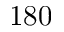Convert formula to latex. <formula><loc_0><loc_0><loc_500><loc_500>1 8 0</formula> 